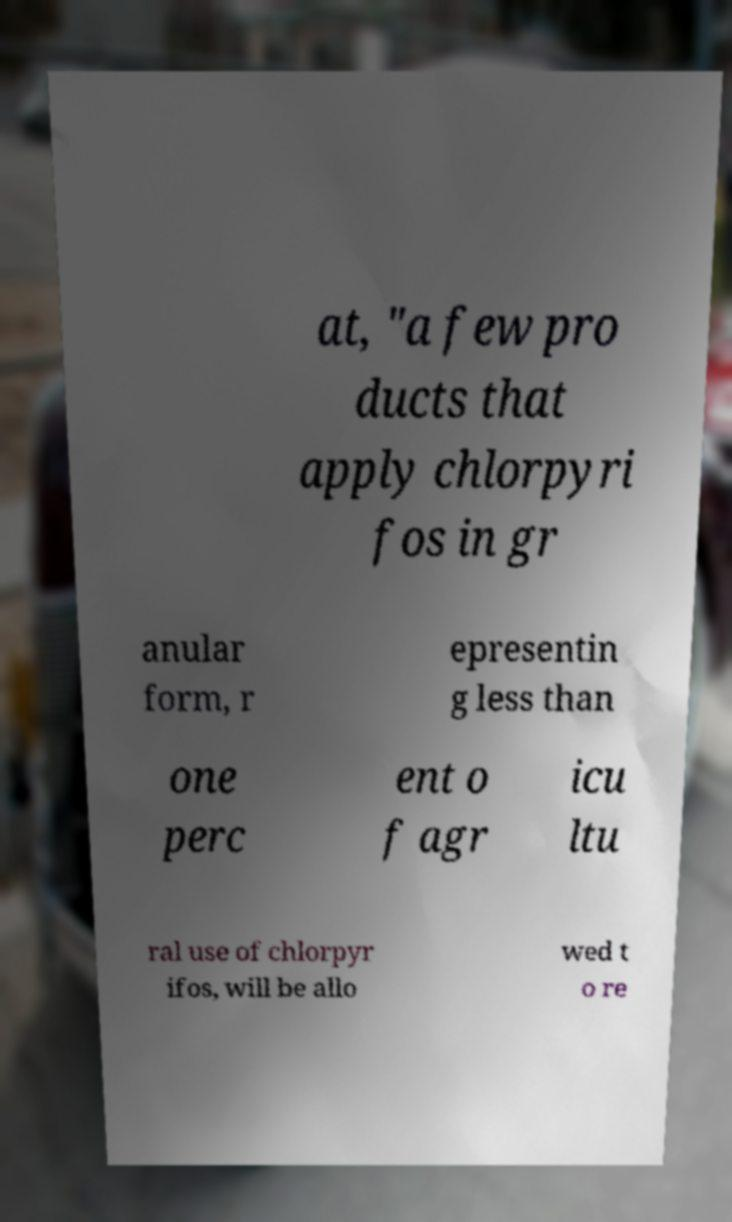Could you assist in decoding the text presented in this image and type it out clearly? at, "a few pro ducts that apply chlorpyri fos in gr anular form, r epresentin g less than one perc ent o f agr icu ltu ral use of chlorpyr ifos, will be allo wed t o re 